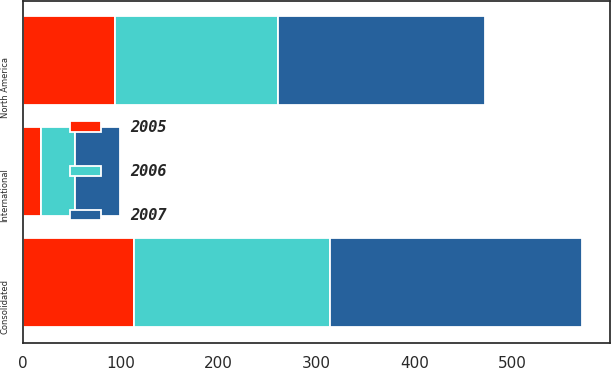Convert chart to OTSL. <chart><loc_0><loc_0><loc_500><loc_500><stacked_bar_chart><ecel><fcel>North America<fcel>International<fcel>Consolidated<nl><fcel>2007<fcel>212<fcel>46<fcel>258<nl><fcel>2006<fcel>166<fcel>34<fcel>200<nl><fcel>2005<fcel>94<fcel>19<fcel>113<nl></chart> 